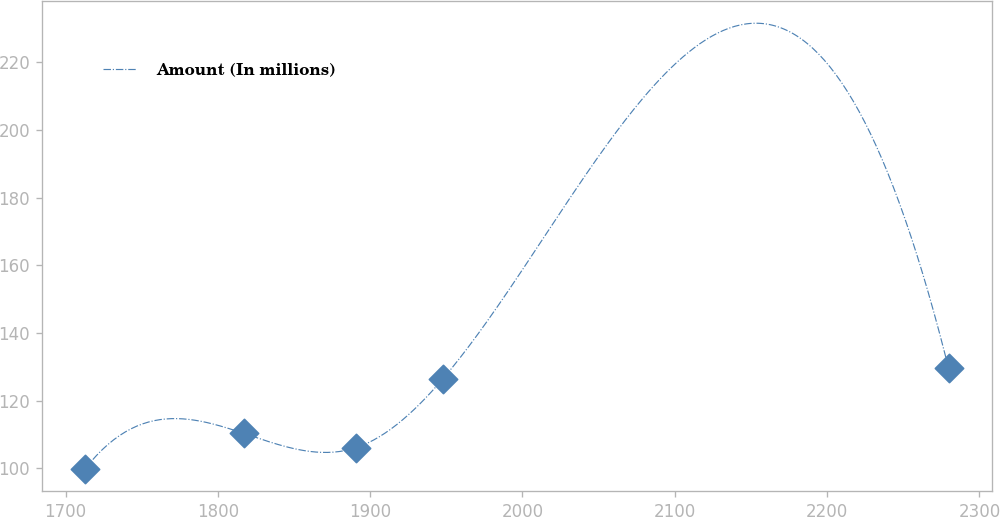<chart> <loc_0><loc_0><loc_500><loc_500><line_chart><ecel><fcel>Amount (In millions)<nl><fcel>1712.73<fcel>99.76<nl><fcel>1816.88<fcel>110.32<nl><fcel>1890.92<fcel>106.1<nl><fcel>1947.62<fcel>126.36<nl><fcel>2279.71<fcel>129.59<nl></chart> 